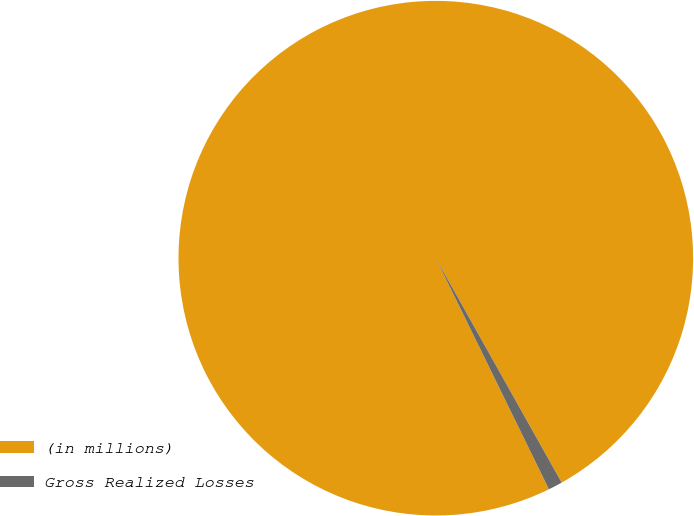<chart> <loc_0><loc_0><loc_500><loc_500><pie_chart><fcel>(in millions)<fcel>Gross Realized Losses<nl><fcel>99.11%<fcel>0.89%<nl></chart> 